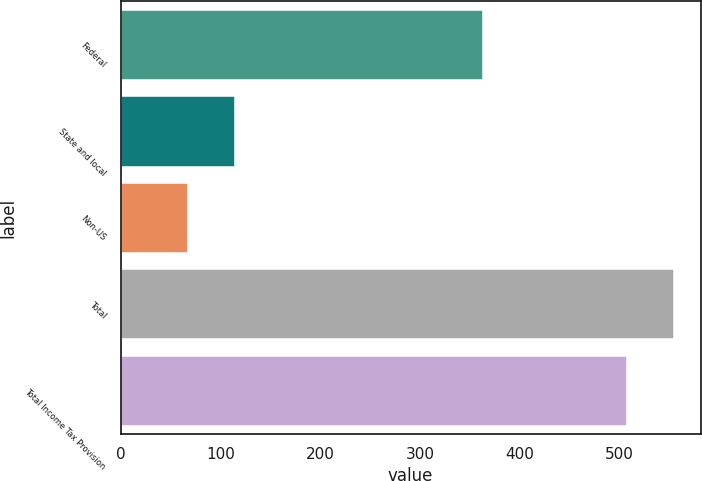<chart> <loc_0><loc_0><loc_500><loc_500><bar_chart><fcel>Federal<fcel>State and local<fcel>Non-US<fcel>Total<fcel>Total Income Tax Provision<nl><fcel>362.2<fcel>113.32<fcel>66.6<fcel>553.32<fcel>506.6<nl></chart> 